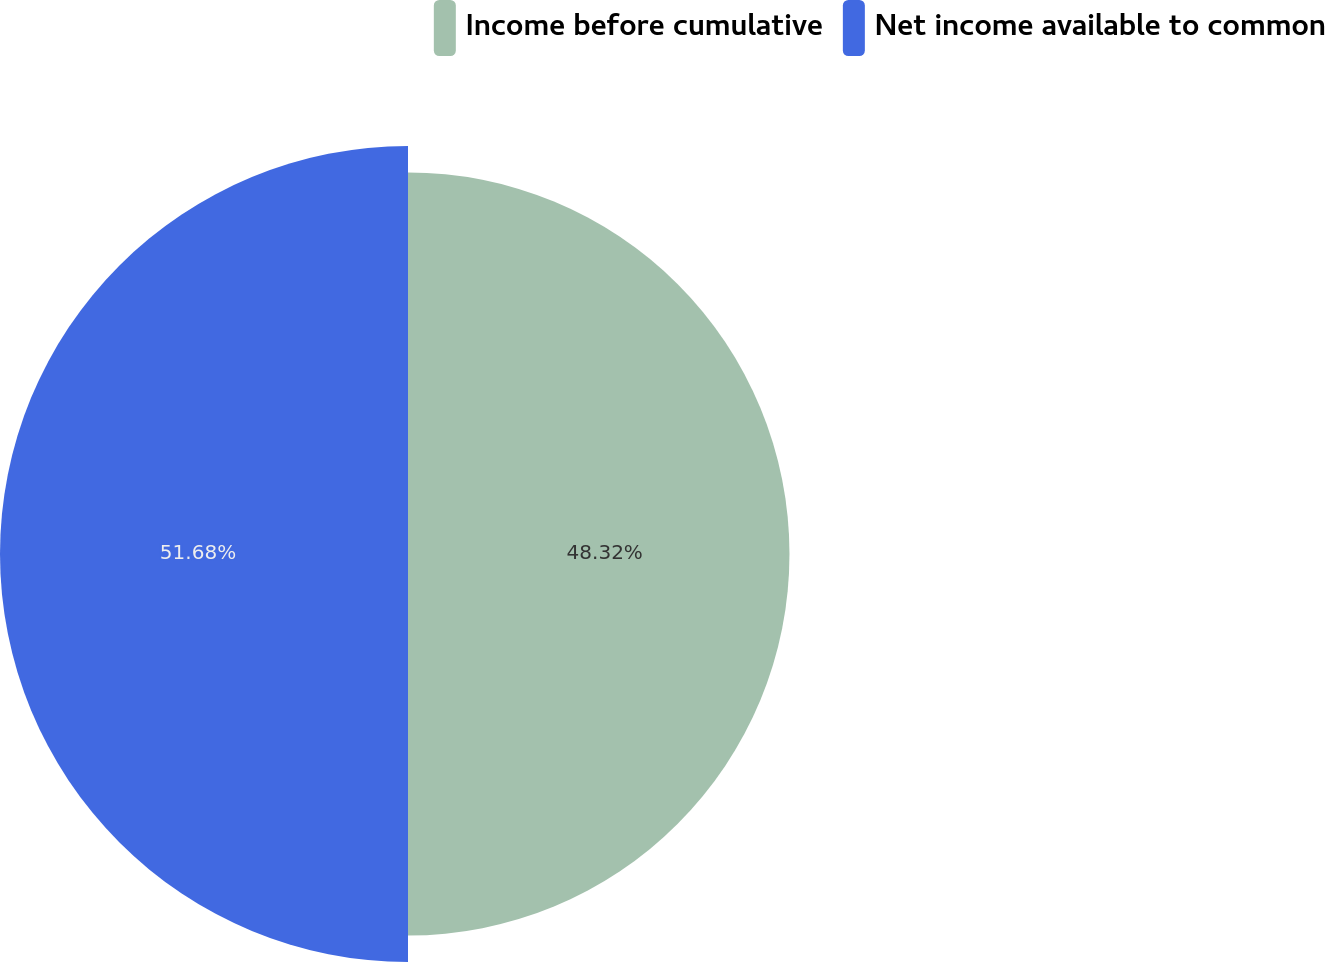Convert chart to OTSL. <chart><loc_0><loc_0><loc_500><loc_500><pie_chart><fcel>Income before cumulative<fcel>Net income available to common<nl><fcel>48.32%<fcel>51.68%<nl></chart> 